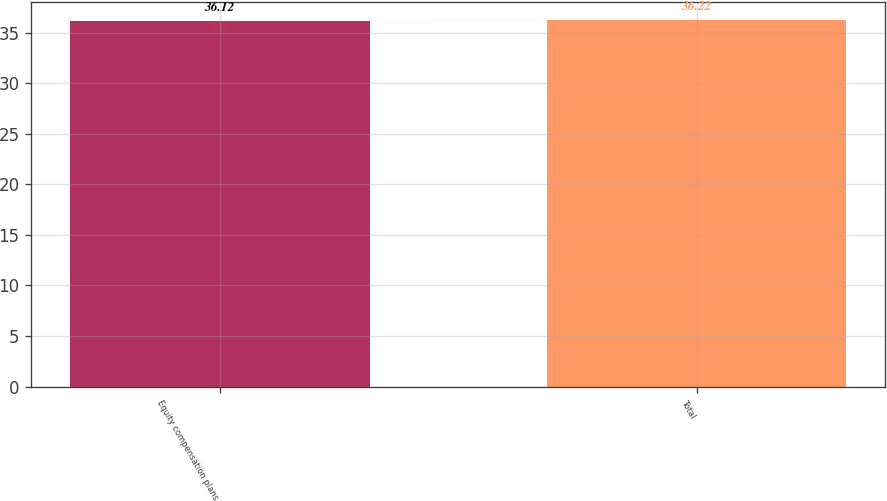<chart> <loc_0><loc_0><loc_500><loc_500><bar_chart><fcel>Equity compensation plans<fcel>Total<nl><fcel>36.12<fcel>36.22<nl></chart> 